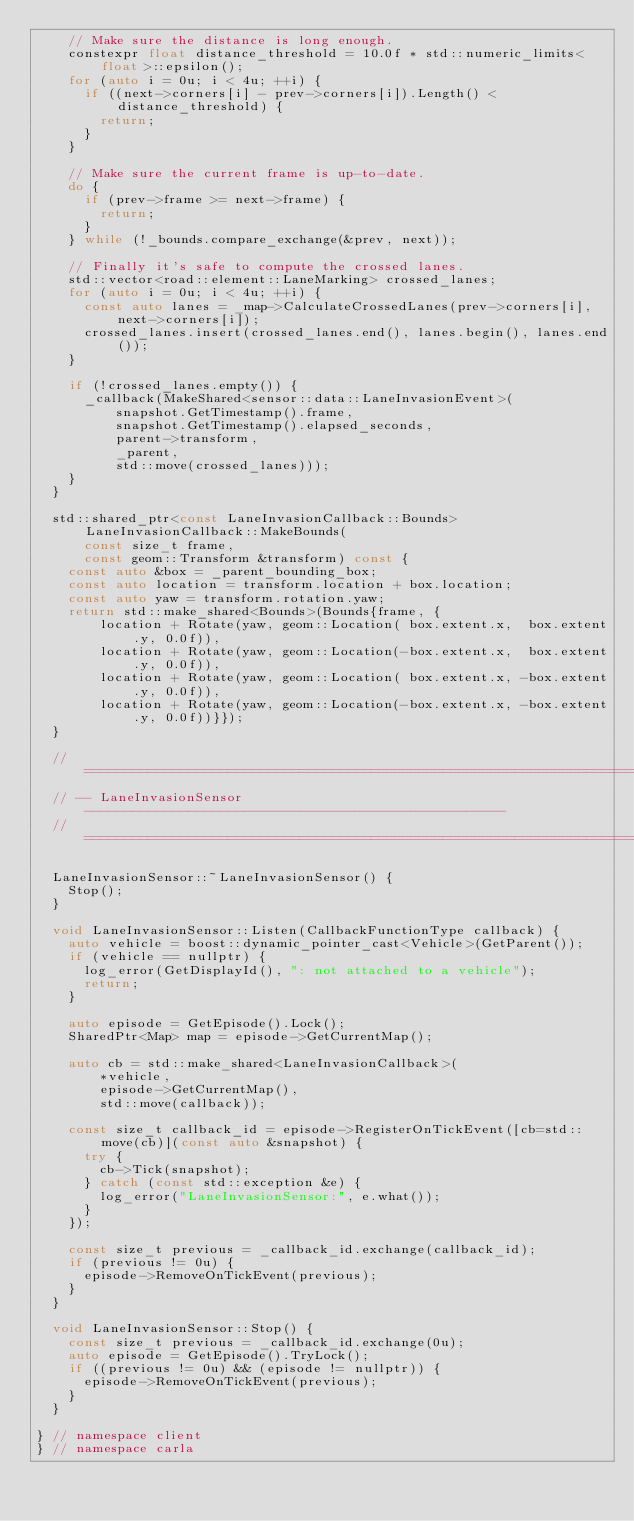Convert code to text. <code><loc_0><loc_0><loc_500><loc_500><_C++_>    // Make sure the distance is long enough.
    constexpr float distance_threshold = 10.0f * std::numeric_limits<float>::epsilon();
    for (auto i = 0u; i < 4u; ++i) {
      if ((next->corners[i] - prev->corners[i]).Length() < distance_threshold) {
        return;
      }
    }

    // Make sure the current frame is up-to-date.
    do {
      if (prev->frame >= next->frame) {
        return;
      }
    } while (!_bounds.compare_exchange(&prev, next));

    // Finally it's safe to compute the crossed lanes.
    std::vector<road::element::LaneMarking> crossed_lanes;
    for (auto i = 0u; i < 4u; ++i) {
      const auto lanes = _map->CalculateCrossedLanes(prev->corners[i], next->corners[i]);
      crossed_lanes.insert(crossed_lanes.end(), lanes.begin(), lanes.end());
    }

    if (!crossed_lanes.empty()) {
      _callback(MakeShared<sensor::data::LaneInvasionEvent>(
          snapshot.GetTimestamp().frame,
          snapshot.GetTimestamp().elapsed_seconds,
          parent->transform,
          _parent,
          std::move(crossed_lanes)));
    }
  }

  std::shared_ptr<const LaneInvasionCallback::Bounds> LaneInvasionCallback::MakeBounds(
      const size_t frame,
      const geom::Transform &transform) const {
    const auto &box = _parent_bounding_box;
    const auto location = transform.location + box.location;
    const auto yaw = transform.rotation.yaw;
    return std::make_shared<Bounds>(Bounds{frame, {
        location + Rotate(yaw, geom::Location( box.extent.x,  box.extent.y, 0.0f)),
        location + Rotate(yaw, geom::Location(-box.extent.x,  box.extent.y, 0.0f)),
        location + Rotate(yaw, geom::Location( box.extent.x, -box.extent.y, 0.0f)),
        location + Rotate(yaw, geom::Location(-box.extent.x, -box.extent.y, 0.0f))}});
  }

  // ===========================================================================
  // -- LaneInvasionSensor -----------------------------------------------------
  // ===========================================================================

  LaneInvasionSensor::~LaneInvasionSensor() {
    Stop();
  }

  void LaneInvasionSensor::Listen(CallbackFunctionType callback) {
    auto vehicle = boost::dynamic_pointer_cast<Vehicle>(GetParent());
    if (vehicle == nullptr) {
      log_error(GetDisplayId(), ": not attached to a vehicle");
      return;
    }

    auto episode = GetEpisode().Lock();
    SharedPtr<Map> map = episode->GetCurrentMap();

    auto cb = std::make_shared<LaneInvasionCallback>(
        *vehicle,
        episode->GetCurrentMap(),
        std::move(callback));

    const size_t callback_id = episode->RegisterOnTickEvent([cb=std::move(cb)](const auto &snapshot) {
      try {
        cb->Tick(snapshot);
      } catch (const std::exception &e) {
        log_error("LaneInvasionSensor:", e.what());
      }
    });

    const size_t previous = _callback_id.exchange(callback_id);
    if (previous != 0u) {
      episode->RemoveOnTickEvent(previous);
    }
  }

  void LaneInvasionSensor::Stop() {
    const size_t previous = _callback_id.exchange(0u);
    auto episode = GetEpisode().TryLock();
    if ((previous != 0u) && (episode != nullptr)) {
      episode->RemoveOnTickEvent(previous);
    }
  }

} // namespace client
} // namespace carla
</code> 